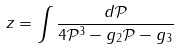<formula> <loc_0><loc_0><loc_500><loc_500>z = \int \frac { d \mathcal { P } } { 4 \mathcal { P } ^ { 3 } - g _ { 2 } \mathcal { P } - g _ { 3 } }</formula> 